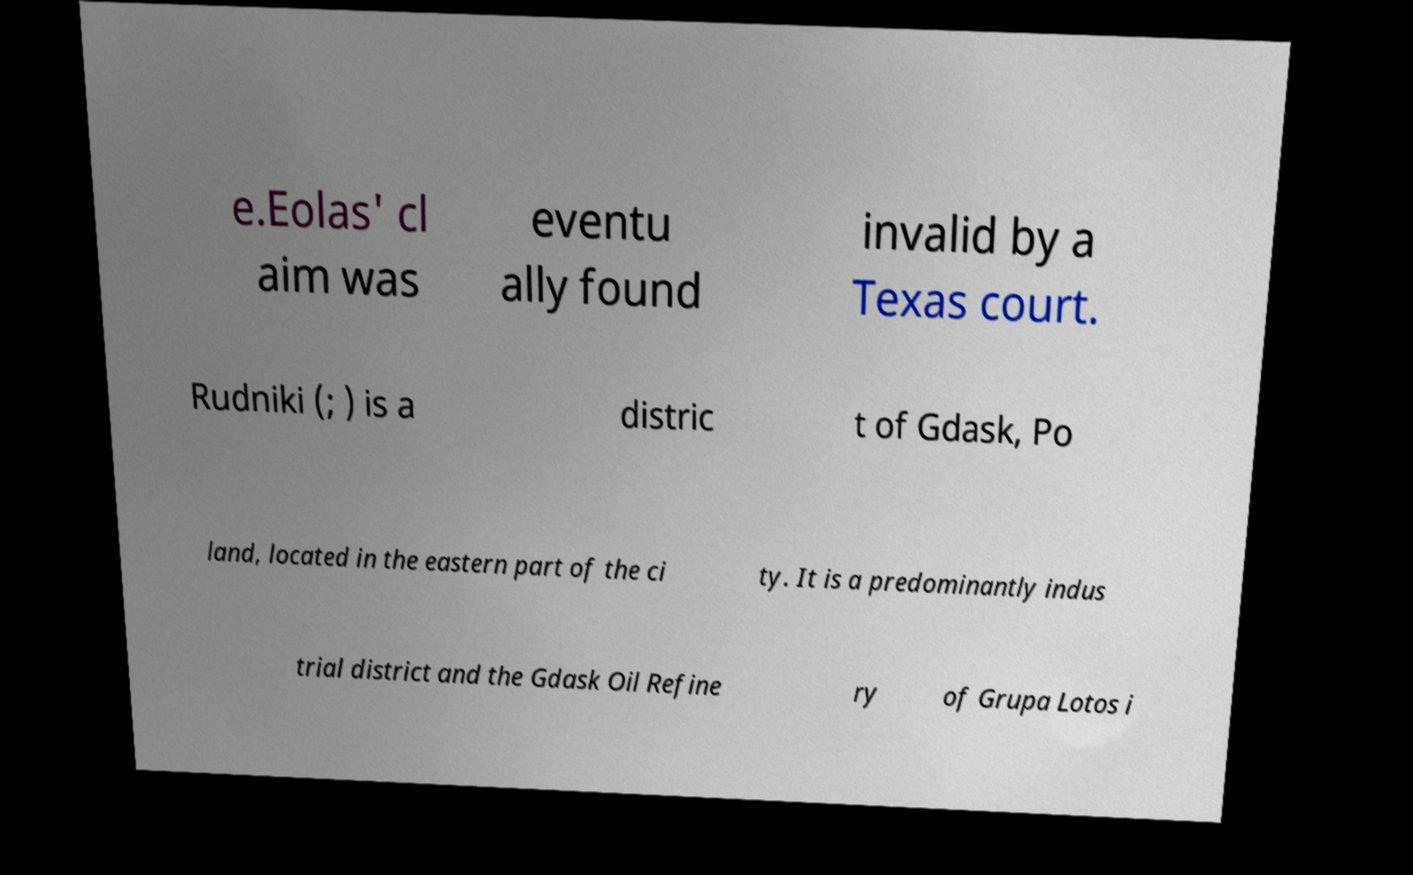Please read and relay the text visible in this image. What does it say? e.Eolas' cl aim was eventu ally found invalid by a Texas court. Rudniki (; ) is a distric t of Gdask, Po land, located in the eastern part of the ci ty. It is a predominantly indus trial district and the Gdask Oil Refine ry of Grupa Lotos i 